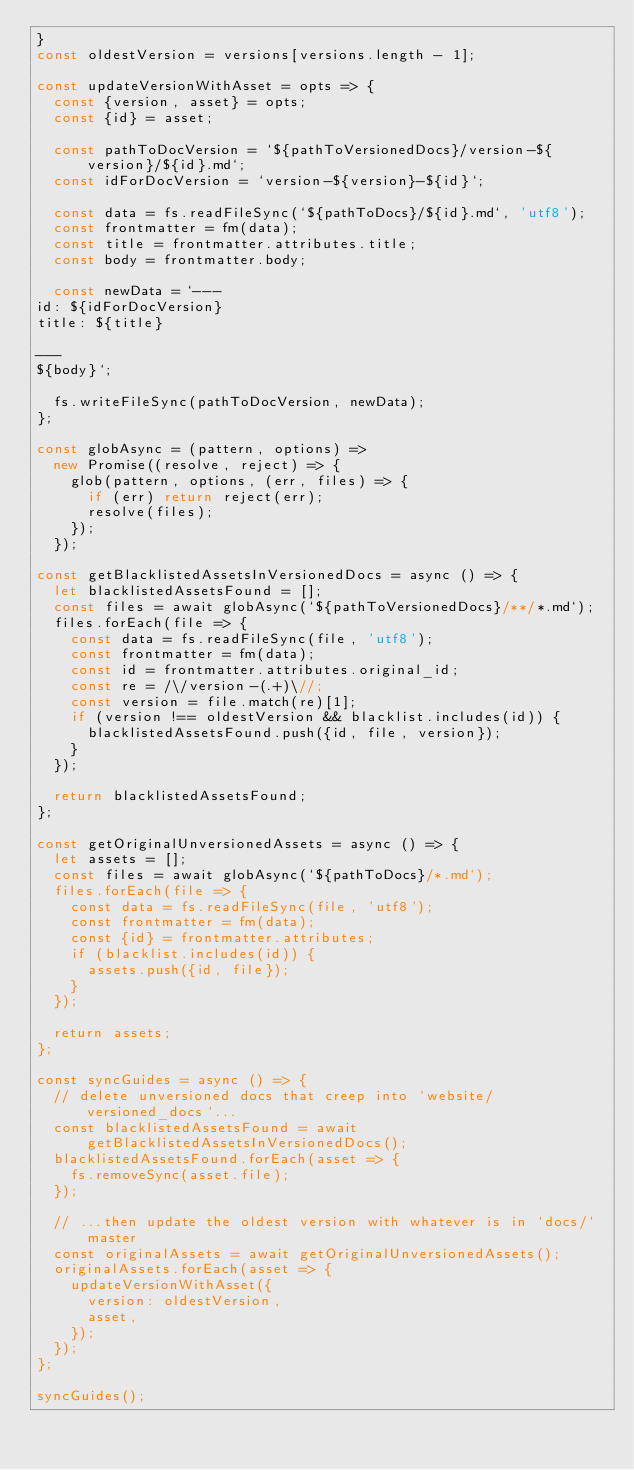Convert code to text. <code><loc_0><loc_0><loc_500><loc_500><_JavaScript_>}
const oldestVersion = versions[versions.length - 1];

const updateVersionWithAsset = opts => {
  const {version, asset} = opts;
  const {id} = asset;

  const pathToDocVersion = `${pathToVersionedDocs}/version-${version}/${id}.md`;
  const idForDocVersion = `version-${version}-${id}`;

  const data = fs.readFileSync(`${pathToDocs}/${id}.md`, 'utf8');
  const frontmatter = fm(data);
  const title = frontmatter.attributes.title;
  const body = frontmatter.body;

  const newData = `---
id: ${idForDocVersion}
title: ${title}
 
---
${body}`;

  fs.writeFileSync(pathToDocVersion, newData);
};

const globAsync = (pattern, options) =>
  new Promise((resolve, reject) => {
    glob(pattern, options, (err, files) => {
      if (err) return reject(err);
      resolve(files);
    });
  });

const getBlacklistedAssetsInVersionedDocs = async () => {
  let blacklistedAssetsFound = [];
  const files = await globAsync(`${pathToVersionedDocs}/**/*.md`);
  files.forEach(file => {
    const data = fs.readFileSync(file, 'utf8');
    const frontmatter = fm(data);
    const id = frontmatter.attributes.original_id;
    const re = /\/version-(.+)\//;
    const version = file.match(re)[1];
    if (version !== oldestVersion && blacklist.includes(id)) {
      blacklistedAssetsFound.push({id, file, version});
    }
  });

  return blacklistedAssetsFound;
};

const getOriginalUnversionedAssets = async () => {
  let assets = [];
  const files = await globAsync(`${pathToDocs}/*.md`);
  files.forEach(file => {
    const data = fs.readFileSync(file, 'utf8');
    const frontmatter = fm(data);
    const {id} = frontmatter.attributes;
    if (blacklist.includes(id)) {
      assets.push({id, file});
    }
  });

  return assets;
};

const syncGuides = async () => {
  // delete unversioned docs that creep into `website/versioned_docs`...
  const blacklistedAssetsFound = await getBlacklistedAssetsInVersionedDocs();
  blacklistedAssetsFound.forEach(asset => {
    fs.removeSync(asset.file);
  });

  // ...then update the oldest version with whatever is in `docs/` master
  const originalAssets = await getOriginalUnversionedAssets();
  originalAssets.forEach(asset => {
    updateVersionWithAsset({
      version: oldestVersion,
      asset,
    });
  });
};

syncGuides();
</code> 